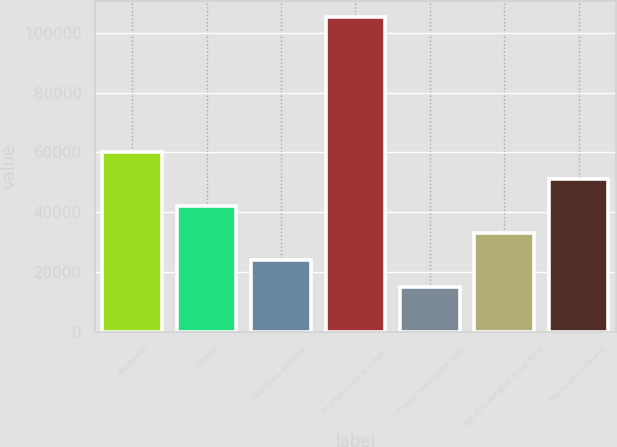<chart> <loc_0><loc_0><loc_500><loc_500><bar_chart><fcel>Residential<fcel>General<fcel>Firm Trans- portation<fcel>Total Firm Sales and Trans-<fcel>Off Peak/ Interruptible Sales<fcel>Non-Firm portation of Gas NYPA<fcel>Plants Total NYPA and<nl><fcel>60258.5<fcel>42253.9<fcel>24249.3<fcel>105270<fcel>15247<fcel>33251.6<fcel>51256.2<nl></chart> 